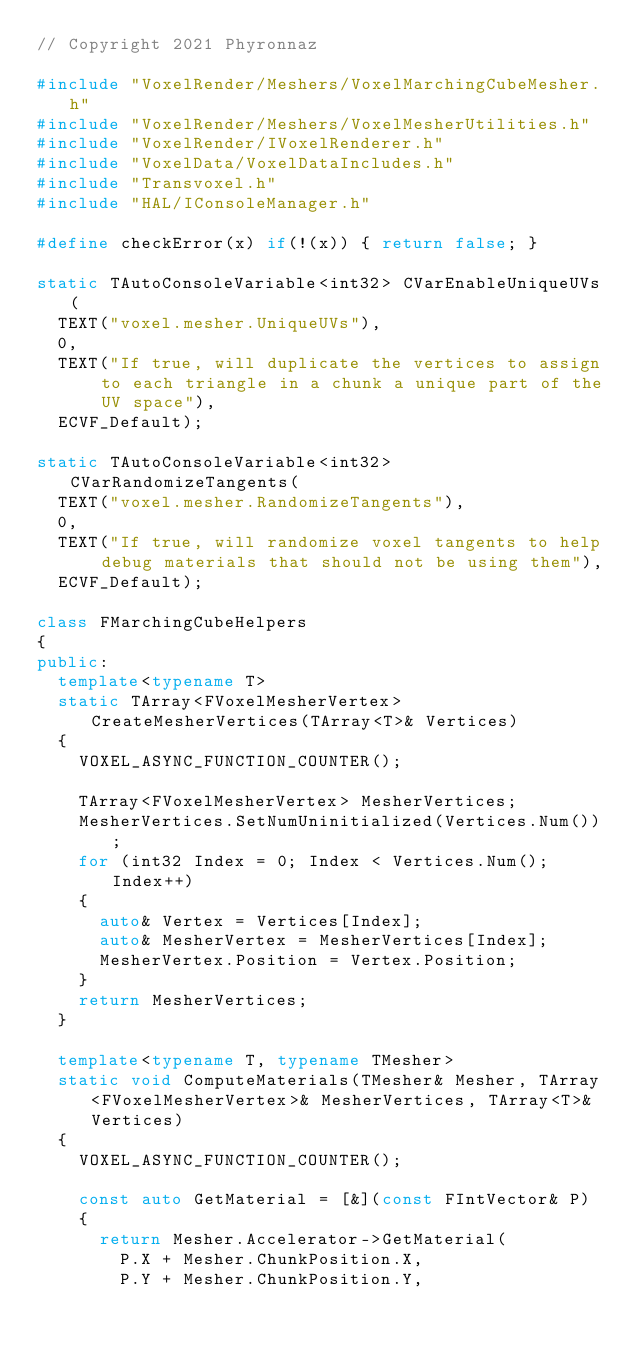Convert code to text. <code><loc_0><loc_0><loc_500><loc_500><_C++_>// Copyright 2021 Phyronnaz

#include "VoxelRender/Meshers/VoxelMarchingCubeMesher.h"
#include "VoxelRender/Meshers/VoxelMesherUtilities.h"
#include "VoxelRender/IVoxelRenderer.h"
#include "VoxelData/VoxelDataIncludes.h"
#include "Transvoxel.h"
#include "HAL/IConsoleManager.h"

#define checkError(x) if(!(x)) { return false; }

static TAutoConsoleVariable<int32> CVarEnableUniqueUVs(
	TEXT("voxel.mesher.UniqueUVs"),
	0,
	TEXT("If true, will duplicate the vertices to assign to each triangle in a chunk a unique part of the UV space"),
	ECVF_Default);

static TAutoConsoleVariable<int32> CVarRandomizeTangents(
	TEXT("voxel.mesher.RandomizeTangents"),
	0,
	TEXT("If true, will randomize voxel tangents to help debug materials that should not be using them"),
	ECVF_Default);

class FMarchingCubeHelpers
{
public:
	template<typename T>
	static TArray<FVoxelMesherVertex> CreateMesherVertices(TArray<T>& Vertices)
	{
		VOXEL_ASYNC_FUNCTION_COUNTER();

		TArray<FVoxelMesherVertex> MesherVertices;
		MesherVertices.SetNumUninitialized(Vertices.Num());
		for (int32 Index = 0; Index < Vertices.Num(); Index++)
		{
			auto& Vertex = Vertices[Index];
			auto& MesherVertex = MesherVertices[Index];
			MesherVertex.Position = Vertex.Position;
		}
		return MesherVertices;
	}
	
	template<typename T, typename TMesher>
	static void ComputeMaterials(TMesher& Mesher, TArray<FVoxelMesherVertex>& MesherVertices, TArray<T>& Vertices)
	{
		VOXEL_ASYNC_FUNCTION_COUNTER();
	
		const auto GetMaterial = [&](const FIntVector& P)
		{
			return Mesher.Accelerator->GetMaterial(
				P.X + Mesher.ChunkPosition.X,
				P.Y + Mesher.ChunkPosition.Y, </code> 